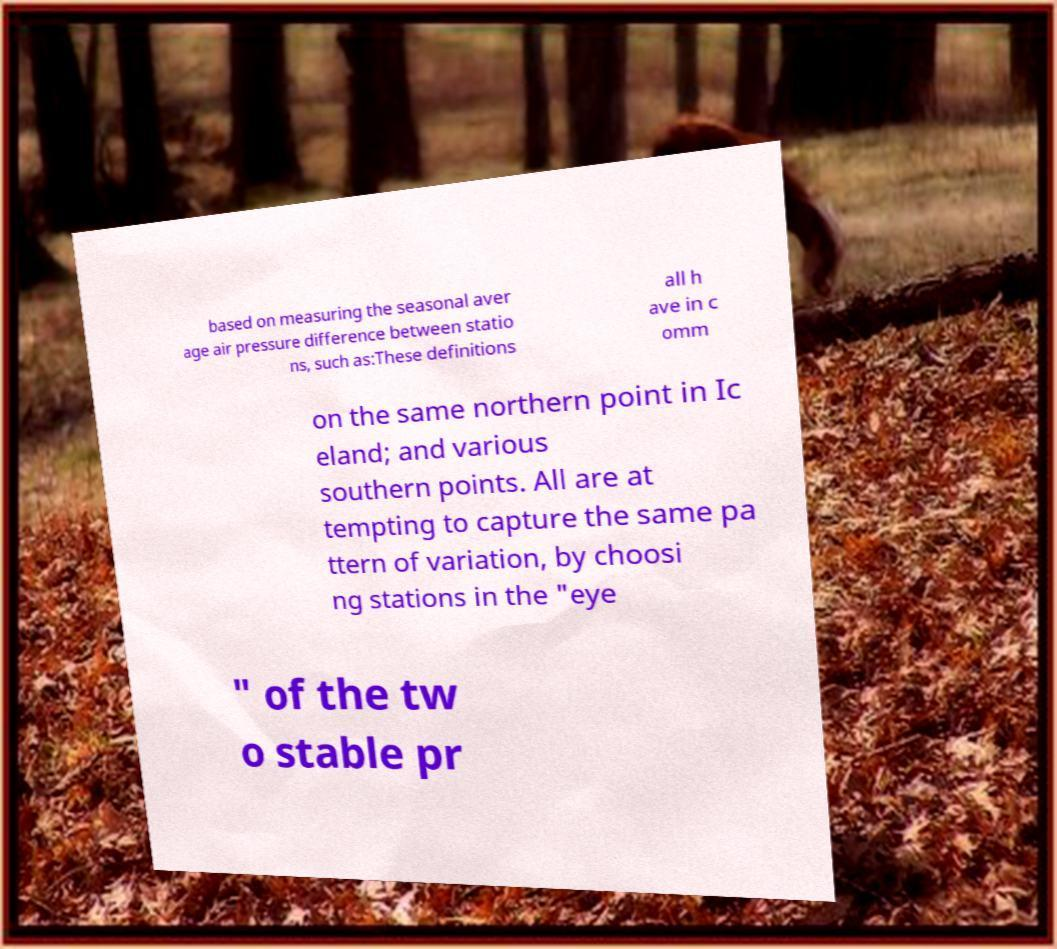Can you accurately transcribe the text from the provided image for me? based on measuring the seasonal aver age air pressure difference between statio ns, such as:These definitions all h ave in c omm on the same northern point in Ic eland; and various southern points. All are at tempting to capture the same pa ttern of variation, by choosi ng stations in the "eye " of the tw o stable pr 